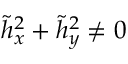Convert formula to latex. <formula><loc_0><loc_0><loc_500><loc_500>\tilde { h } _ { x } ^ { 2 } + \tilde { h } _ { y } ^ { 2 } \ne 0</formula> 